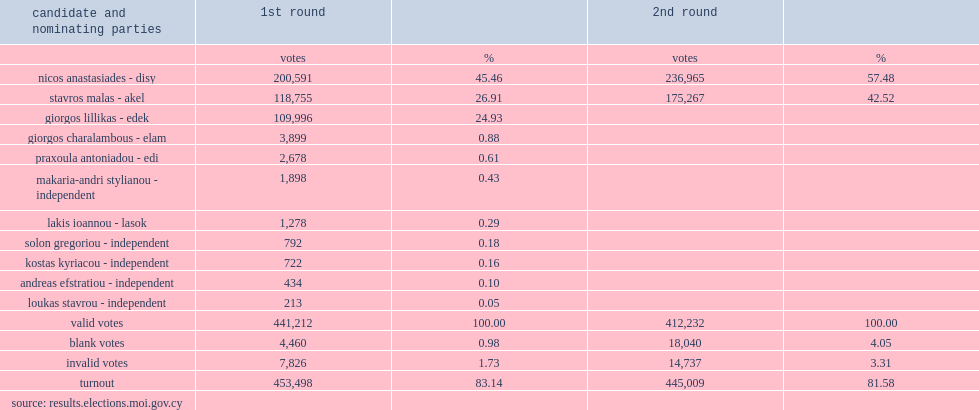How many percent of the vote did nicos anastasiades win the presidential election with 57.48% of the vote? 57.48. How many percent of the vote did stavros malas receive? 42.52. 